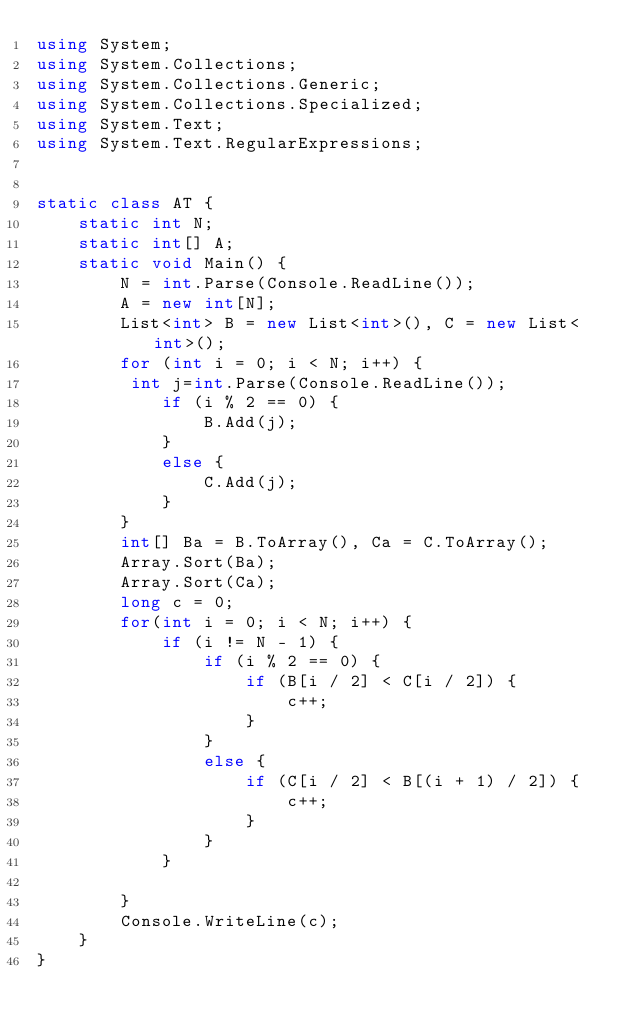<code> <loc_0><loc_0><loc_500><loc_500><_C#_>using System;
using System.Collections;
using System.Collections.Generic;
using System.Collections.Specialized;
using System.Text;
using System.Text.RegularExpressions;


static class AT {
    static int N;
    static int[] A;
    static void Main() {
        N = int.Parse(Console.ReadLine());
        A = new int[N];
        List<int> B = new List<int>(), C = new List<int>();
        for (int i = 0; i < N; i++) {
         int j=int.Parse(Console.ReadLine());
            if (i % 2 == 0) {
                B.Add(j);
            }
            else {
                C.Add(j);
            }
        }
        int[] Ba = B.ToArray(), Ca = C.ToArray();
        Array.Sort(Ba);
        Array.Sort(Ca);
        long c = 0;
        for(int i = 0; i < N; i++) {
            if (i != N - 1) {
                if (i % 2 == 0) {
                    if (B[i / 2] < C[i / 2]) {
                        c++;
                    }
                }
                else {
                    if (C[i / 2] < B[(i + 1) / 2]) {
                        c++;
                    }
                }
            }
        
        }
        Console.WriteLine(c);
    }
}
</code> 